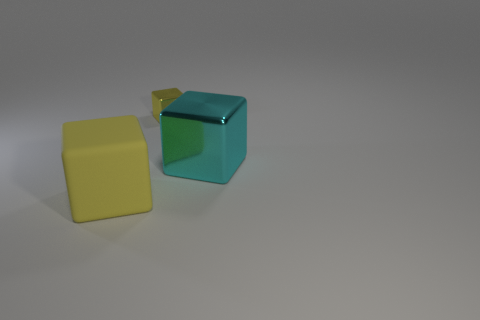Add 3 big things. How many objects exist? 6 Subtract all rubber spheres. Subtract all small yellow shiny things. How many objects are left? 2 Add 3 small yellow cubes. How many small yellow cubes are left? 4 Add 1 tiny cubes. How many tiny cubes exist? 2 Subtract 0 purple cylinders. How many objects are left? 3 